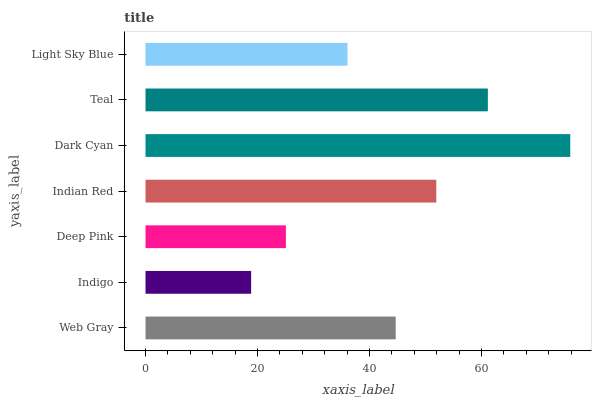Is Indigo the minimum?
Answer yes or no. Yes. Is Dark Cyan the maximum?
Answer yes or no. Yes. Is Deep Pink the minimum?
Answer yes or no. No. Is Deep Pink the maximum?
Answer yes or no. No. Is Deep Pink greater than Indigo?
Answer yes or no. Yes. Is Indigo less than Deep Pink?
Answer yes or no. Yes. Is Indigo greater than Deep Pink?
Answer yes or no. No. Is Deep Pink less than Indigo?
Answer yes or no. No. Is Web Gray the high median?
Answer yes or no. Yes. Is Web Gray the low median?
Answer yes or no. Yes. Is Indigo the high median?
Answer yes or no. No. Is Teal the low median?
Answer yes or no. No. 